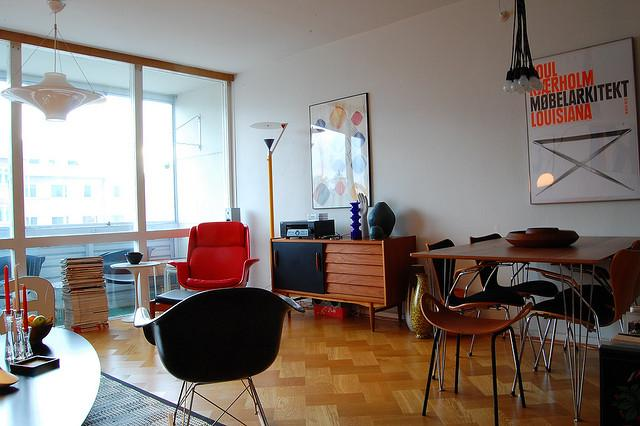What is next to the table on the left?

Choices:
A) green chair
B) black chair
C) baby
D) cow black chair 